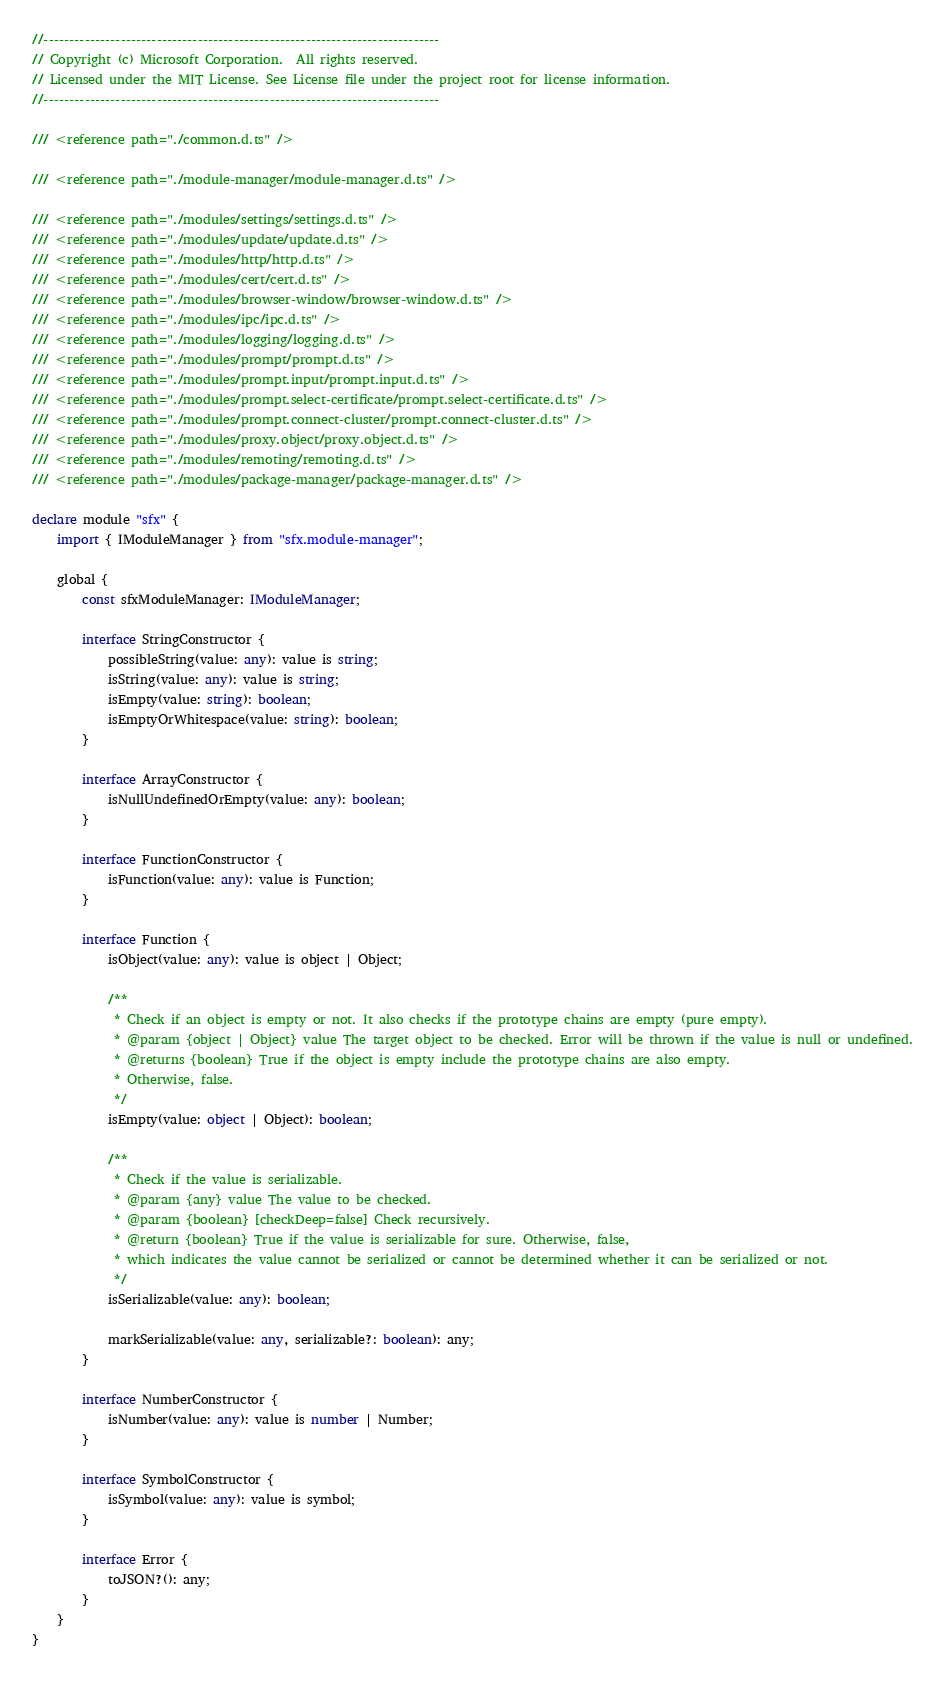Convert code to text. <code><loc_0><loc_0><loc_500><loc_500><_TypeScript_>//-----------------------------------------------------------------------------
// Copyright (c) Microsoft Corporation.  All rights reserved.
// Licensed under the MIT License. See License file under the project root for license information.
//-----------------------------------------------------------------------------

/// <reference path="./common.d.ts" />

/// <reference path="./module-manager/module-manager.d.ts" />

/// <reference path="./modules/settings/settings.d.ts" />
/// <reference path="./modules/update/update.d.ts" />
/// <reference path="./modules/http/http.d.ts" />
/// <reference path="./modules/cert/cert.d.ts" />
/// <reference path="./modules/browser-window/browser-window.d.ts" />
/// <reference path="./modules/ipc/ipc.d.ts" />
/// <reference path="./modules/logging/logging.d.ts" />
/// <reference path="./modules/prompt/prompt.d.ts" />
/// <reference path="./modules/prompt.input/prompt.input.d.ts" />
/// <reference path="./modules/prompt.select-certificate/prompt.select-certificate.d.ts" />
/// <reference path="./modules/prompt.connect-cluster/prompt.connect-cluster.d.ts" />
/// <reference path="./modules/proxy.object/proxy.object.d.ts" />
/// <reference path="./modules/remoting/remoting.d.ts" />
/// <reference path="./modules/package-manager/package-manager.d.ts" />

declare module "sfx" {
    import { IModuleManager } from "sfx.module-manager";

    global {
        const sfxModuleManager: IModuleManager;
        
        interface StringConstructor {
            possibleString(value: any): value is string;
            isString(value: any): value is string;
            isEmpty(value: string): boolean;
            isEmptyOrWhitespace(value: string): boolean;
        }
    
        interface ArrayConstructor {
            isNullUndefinedOrEmpty(value: any): boolean;
        }
    
        interface FunctionConstructor {
            isFunction(value: any): value is Function;
        }
    
        interface Function {
            isObject(value: any): value is object | Object;
    
            /**
             * Check if an object is empty or not. It also checks if the prototype chains are empty (pure empty).
             * @param {object | Object} value The target object to be checked. Error will be thrown if the value is null or undefined.
             * @returns {boolean} True if the object is empty include the prototype chains are also empty. 
             * Otherwise, false.
             */
            isEmpty(value: object | Object): boolean;
    
            /**
             * Check if the value is serializable. 
             * @param {any} value The value to be checked.
             * @param {boolean} [checkDeep=false] Check recursively.
             * @return {boolean} True if the value is serializable for sure. Otherwise, false, 
             * which indicates the value cannot be serialized or cannot be determined whether it can be serialized or not.
             */
            isSerializable(value: any): boolean;
    
            markSerializable(value: any, serializable?: boolean): any;
        }
    
        interface NumberConstructor {
            isNumber(value: any): value is number | Number;
        }
    
        interface SymbolConstructor {
            isSymbol(value: any): value is symbol;
        }
    
        interface Error {
            toJSON?(): any;
        }
    }
}
</code> 